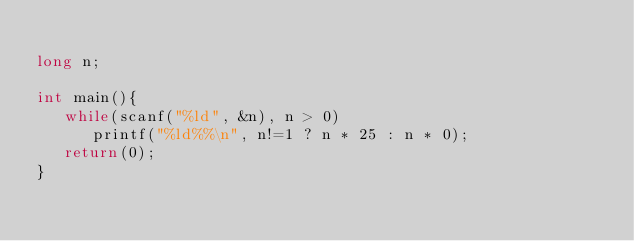<code> <loc_0><loc_0><loc_500><loc_500><_C++_>
long n;

int main(){
   while(scanf("%ld", &n), n > 0)
      printf("%ld%%\n", n!=1 ? n * 25 : n * 0);
   return(0);
}
</code> 